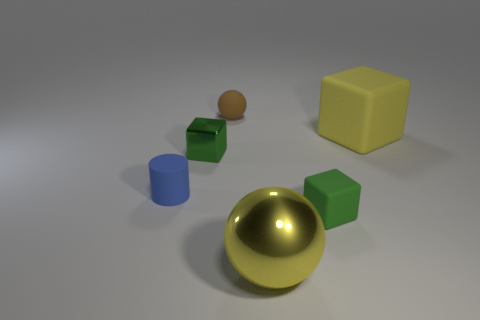Add 1 big yellow metal things. How many objects exist? 7 Subtract all blue spheres. Subtract all yellow cylinders. How many spheres are left? 2 Subtract all balls. How many objects are left? 4 Add 6 cylinders. How many cylinders exist? 7 Subtract 0 red cylinders. How many objects are left? 6 Subtract all matte cylinders. Subtract all yellow objects. How many objects are left? 3 Add 6 tiny objects. How many tiny objects are left? 10 